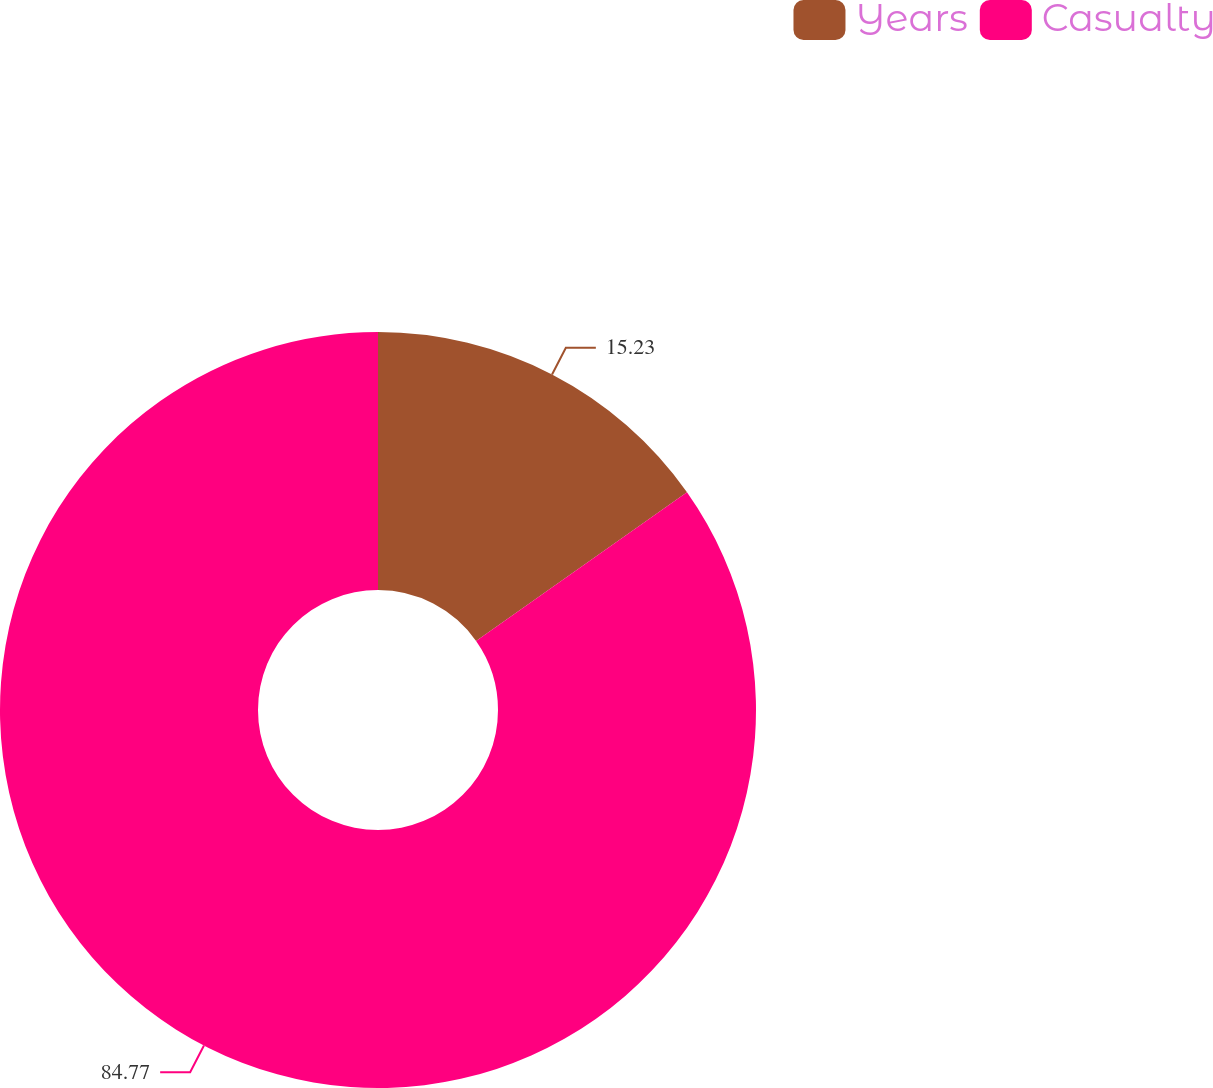Convert chart. <chart><loc_0><loc_0><loc_500><loc_500><pie_chart><fcel>Years<fcel>Casualty<nl><fcel>15.23%<fcel>84.77%<nl></chart> 